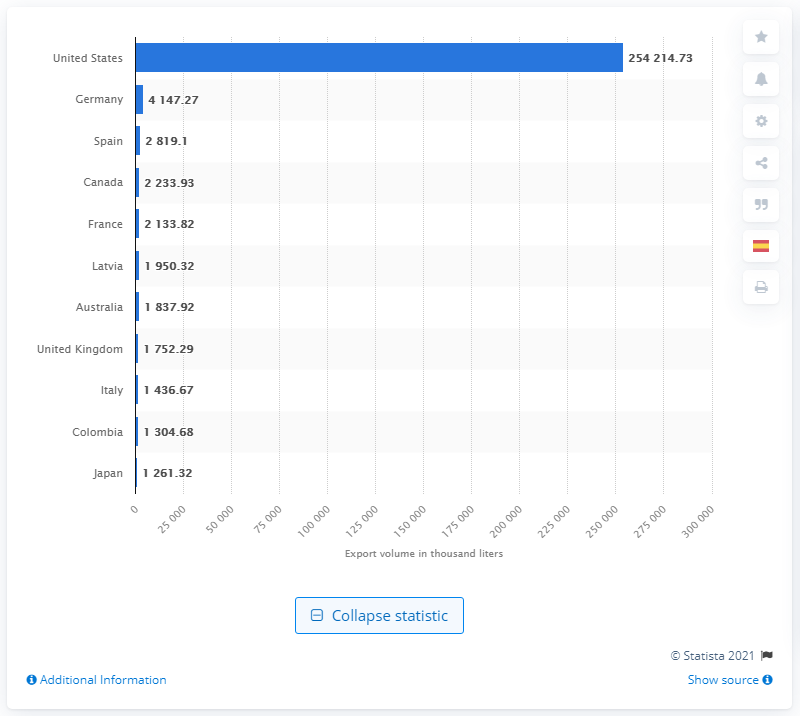Give some essential details in this illustration. Mexico's second most important tequila export partner is Germany. 